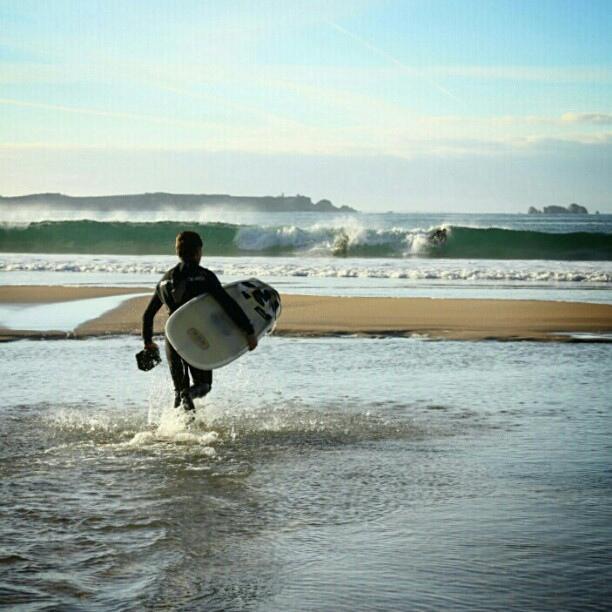How many dogs are standing in boat?
Give a very brief answer. 0. 